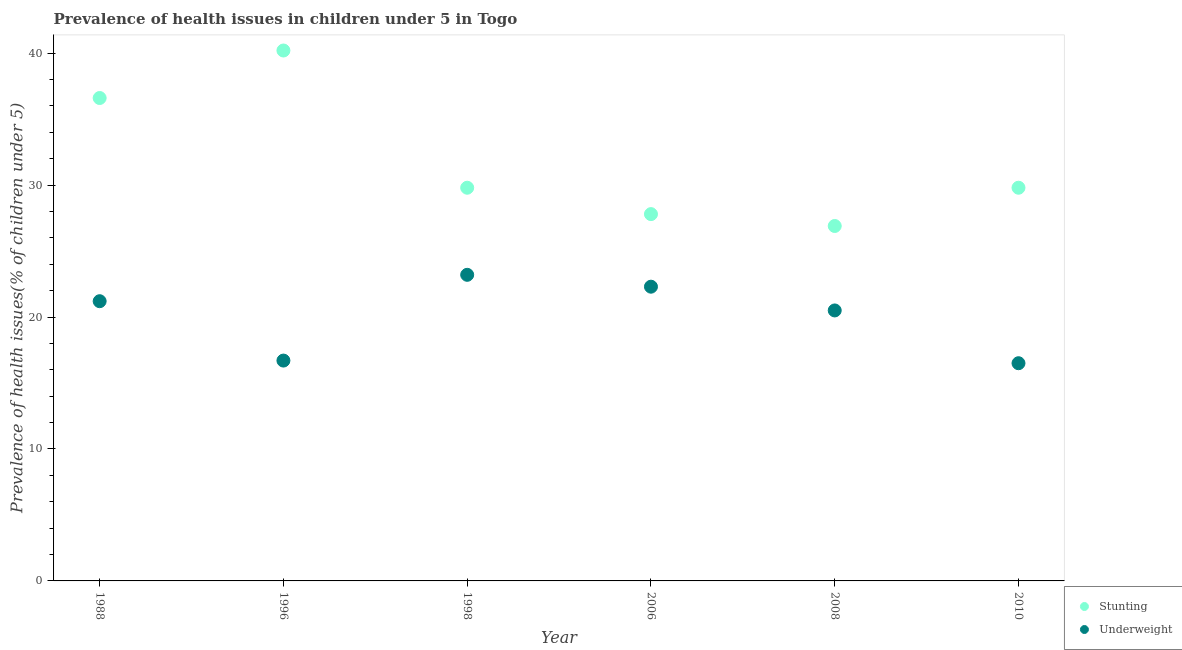Is the number of dotlines equal to the number of legend labels?
Your response must be concise. Yes. Across all years, what is the maximum percentage of underweight children?
Offer a very short reply. 23.2. Across all years, what is the minimum percentage of stunted children?
Give a very brief answer. 26.9. In which year was the percentage of underweight children minimum?
Your answer should be compact. 2010. What is the total percentage of stunted children in the graph?
Ensure brevity in your answer.  191.1. What is the difference between the percentage of stunted children in 1998 and that in 2008?
Your answer should be very brief. 2.9. What is the difference between the percentage of stunted children in 2010 and the percentage of underweight children in 1998?
Provide a succinct answer. 6.6. What is the average percentage of underweight children per year?
Make the answer very short. 20.07. In the year 2008, what is the difference between the percentage of underweight children and percentage of stunted children?
Provide a short and direct response. -6.4. In how many years, is the percentage of underweight children greater than 38 %?
Provide a succinct answer. 0. What is the ratio of the percentage of stunted children in 1988 to that in 2010?
Offer a very short reply. 1.23. Is the percentage of stunted children in 2006 less than that in 2008?
Ensure brevity in your answer.  No. Is the difference between the percentage of stunted children in 1996 and 2008 greater than the difference between the percentage of underweight children in 1996 and 2008?
Your answer should be very brief. Yes. What is the difference between the highest and the second highest percentage of underweight children?
Keep it short and to the point. 0.9. What is the difference between the highest and the lowest percentage of underweight children?
Offer a terse response. 6.7. In how many years, is the percentage of underweight children greater than the average percentage of underweight children taken over all years?
Your answer should be very brief. 4. How many dotlines are there?
Make the answer very short. 2. Does the graph contain any zero values?
Make the answer very short. No. Does the graph contain grids?
Your answer should be compact. No. Where does the legend appear in the graph?
Offer a terse response. Bottom right. How are the legend labels stacked?
Your answer should be very brief. Vertical. What is the title of the graph?
Keep it short and to the point. Prevalence of health issues in children under 5 in Togo. What is the label or title of the Y-axis?
Provide a succinct answer. Prevalence of health issues(% of children under 5). What is the Prevalence of health issues(% of children under 5) in Stunting in 1988?
Make the answer very short. 36.6. What is the Prevalence of health issues(% of children under 5) in Underweight in 1988?
Offer a very short reply. 21.2. What is the Prevalence of health issues(% of children under 5) of Stunting in 1996?
Give a very brief answer. 40.2. What is the Prevalence of health issues(% of children under 5) of Underweight in 1996?
Offer a very short reply. 16.7. What is the Prevalence of health issues(% of children under 5) in Stunting in 1998?
Make the answer very short. 29.8. What is the Prevalence of health issues(% of children under 5) of Underweight in 1998?
Offer a terse response. 23.2. What is the Prevalence of health issues(% of children under 5) in Stunting in 2006?
Offer a terse response. 27.8. What is the Prevalence of health issues(% of children under 5) of Underweight in 2006?
Your answer should be very brief. 22.3. What is the Prevalence of health issues(% of children under 5) of Stunting in 2008?
Give a very brief answer. 26.9. What is the Prevalence of health issues(% of children under 5) of Underweight in 2008?
Provide a succinct answer. 20.5. What is the Prevalence of health issues(% of children under 5) in Stunting in 2010?
Offer a very short reply. 29.8. What is the Prevalence of health issues(% of children under 5) in Underweight in 2010?
Your response must be concise. 16.5. Across all years, what is the maximum Prevalence of health issues(% of children under 5) of Stunting?
Give a very brief answer. 40.2. Across all years, what is the maximum Prevalence of health issues(% of children under 5) of Underweight?
Ensure brevity in your answer.  23.2. Across all years, what is the minimum Prevalence of health issues(% of children under 5) of Stunting?
Provide a succinct answer. 26.9. What is the total Prevalence of health issues(% of children under 5) of Stunting in the graph?
Make the answer very short. 191.1. What is the total Prevalence of health issues(% of children under 5) in Underweight in the graph?
Your answer should be compact. 120.4. What is the difference between the Prevalence of health issues(% of children under 5) of Underweight in 1988 and that in 1996?
Give a very brief answer. 4.5. What is the difference between the Prevalence of health issues(% of children under 5) of Stunting in 1988 and that in 2008?
Make the answer very short. 9.7. What is the difference between the Prevalence of health issues(% of children under 5) in Stunting in 1988 and that in 2010?
Offer a terse response. 6.8. What is the difference between the Prevalence of health issues(% of children under 5) of Stunting in 1996 and that in 1998?
Your response must be concise. 10.4. What is the difference between the Prevalence of health issues(% of children under 5) in Underweight in 1996 and that in 2006?
Your answer should be very brief. -5.6. What is the difference between the Prevalence of health issues(% of children under 5) in Stunting in 1996 and that in 2008?
Give a very brief answer. 13.3. What is the difference between the Prevalence of health issues(% of children under 5) of Underweight in 1996 and that in 2008?
Make the answer very short. -3.8. What is the difference between the Prevalence of health issues(% of children under 5) of Underweight in 1996 and that in 2010?
Give a very brief answer. 0.2. What is the difference between the Prevalence of health issues(% of children under 5) in Stunting in 1998 and that in 2006?
Keep it short and to the point. 2. What is the difference between the Prevalence of health issues(% of children under 5) in Underweight in 1998 and that in 2008?
Offer a terse response. 2.7. What is the difference between the Prevalence of health issues(% of children under 5) in Stunting in 1998 and that in 2010?
Provide a succinct answer. 0. What is the difference between the Prevalence of health issues(% of children under 5) of Stunting in 2006 and that in 2010?
Offer a very short reply. -2. What is the difference between the Prevalence of health issues(% of children under 5) of Stunting in 2008 and that in 2010?
Give a very brief answer. -2.9. What is the difference between the Prevalence of health issues(% of children under 5) in Underweight in 2008 and that in 2010?
Keep it short and to the point. 4. What is the difference between the Prevalence of health issues(% of children under 5) of Stunting in 1988 and the Prevalence of health issues(% of children under 5) of Underweight in 2010?
Give a very brief answer. 20.1. What is the difference between the Prevalence of health issues(% of children under 5) of Stunting in 1996 and the Prevalence of health issues(% of children under 5) of Underweight in 1998?
Ensure brevity in your answer.  17. What is the difference between the Prevalence of health issues(% of children under 5) in Stunting in 1996 and the Prevalence of health issues(% of children under 5) in Underweight in 2006?
Provide a short and direct response. 17.9. What is the difference between the Prevalence of health issues(% of children under 5) of Stunting in 1996 and the Prevalence of health issues(% of children under 5) of Underweight in 2010?
Provide a succinct answer. 23.7. What is the difference between the Prevalence of health issues(% of children under 5) in Stunting in 1998 and the Prevalence of health issues(% of children under 5) in Underweight in 2006?
Provide a short and direct response. 7.5. What is the difference between the Prevalence of health issues(% of children under 5) of Stunting in 2006 and the Prevalence of health issues(% of children under 5) of Underweight in 2008?
Keep it short and to the point. 7.3. What is the average Prevalence of health issues(% of children under 5) in Stunting per year?
Your response must be concise. 31.85. What is the average Prevalence of health issues(% of children under 5) of Underweight per year?
Offer a very short reply. 20.07. In the year 1988, what is the difference between the Prevalence of health issues(% of children under 5) in Stunting and Prevalence of health issues(% of children under 5) in Underweight?
Your answer should be very brief. 15.4. In the year 1998, what is the difference between the Prevalence of health issues(% of children under 5) of Stunting and Prevalence of health issues(% of children under 5) of Underweight?
Offer a very short reply. 6.6. In the year 2006, what is the difference between the Prevalence of health issues(% of children under 5) of Stunting and Prevalence of health issues(% of children under 5) of Underweight?
Ensure brevity in your answer.  5.5. In the year 2010, what is the difference between the Prevalence of health issues(% of children under 5) of Stunting and Prevalence of health issues(% of children under 5) of Underweight?
Your answer should be very brief. 13.3. What is the ratio of the Prevalence of health issues(% of children under 5) in Stunting in 1988 to that in 1996?
Make the answer very short. 0.91. What is the ratio of the Prevalence of health issues(% of children under 5) of Underweight in 1988 to that in 1996?
Provide a short and direct response. 1.27. What is the ratio of the Prevalence of health issues(% of children under 5) in Stunting in 1988 to that in 1998?
Provide a succinct answer. 1.23. What is the ratio of the Prevalence of health issues(% of children under 5) of Underweight in 1988 to that in 1998?
Your answer should be very brief. 0.91. What is the ratio of the Prevalence of health issues(% of children under 5) of Stunting in 1988 to that in 2006?
Offer a very short reply. 1.32. What is the ratio of the Prevalence of health issues(% of children under 5) in Underweight in 1988 to that in 2006?
Your answer should be very brief. 0.95. What is the ratio of the Prevalence of health issues(% of children under 5) of Stunting in 1988 to that in 2008?
Your response must be concise. 1.36. What is the ratio of the Prevalence of health issues(% of children under 5) of Underweight in 1988 to that in 2008?
Ensure brevity in your answer.  1.03. What is the ratio of the Prevalence of health issues(% of children under 5) of Stunting in 1988 to that in 2010?
Ensure brevity in your answer.  1.23. What is the ratio of the Prevalence of health issues(% of children under 5) in Underweight in 1988 to that in 2010?
Provide a short and direct response. 1.28. What is the ratio of the Prevalence of health issues(% of children under 5) of Stunting in 1996 to that in 1998?
Make the answer very short. 1.35. What is the ratio of the Prevalence of health issues(% of children under 5) in Underweight in 1996 to that in 1998?
Give a very brief answer. 0.72. What is the ratio of the Prevalence of health issues(% of children under 5) of Stunting in 1996 to that in 2006?
Your response must be concise. 1.45. What is the ratio of the Prevalence of health issues(% of children under 5) in Underweight in 1996 to that in 2006?
Make the answer very short. 0.75. What is the ratio of the Prevalence of health issues(% of children under 5) in Stunting in 1996 to that in 2008?
Your response must be concise. 1.49. What is the ratio of the Prevalence of health issues(% of children under 5) of Underweight in 1996 to that in 2008?
Offer a terse response. 0.81. What is the ratio of the Prevalence of health issues(% of children under 5) in Stunting in 1996 to that in 2010?
Keep it short and to the point. 1.35. What is the ratio of the Prevalence of health issues(% of children under 5) of Underweight in 1996 to that in 2010?
Provide a succinct answer. 1.01. What is the ratio of the Prevalence of health issues(% of children under 5) in Stunting in 1998 to that in 2006?
Make the answer very short. 1.07. What is the ratio of the Prevalence of health issues(% of children under 5) in Underweight in 1998 to that in 2006?
Offer a terse response. 1.04. What is the ratio of the Prevalence of health issues(% of children under 5) of Stunting in 1998 to that in 2008?
Keep it short and to the point. 1.11. What is the ratio of the Prevalence of health issues(% of children under 5) in Underweight in 1998 to that in 2008?
Your answer should be compact. 1.13. What is the ratio of the Prevalence of health issues(% of children under 5) of Stunting in 1998 to that in 2010?
Offer a very short reply. 1. What is the ratio of the Prevalence of health issues(% of children under 5) in Underweight in 1998 to that in 2010?
Make the answer very short. 1.41. What is the ratio of the Prevalence of health issues(% of children under 5) in Stunting in 2006 to that in 2008?
Give a very brief answer. 1.03. What is the ratio of the Prevalence of health issues(% of children under 5) in Underweight in 2006 to that in 2008?
Ensure brevity in your answer.  1.09. What is the ratio of the Prevalence of health issues(% of children under 5) of Stunting in 2006 to that in 2010?
Your answer should be compact. 0.93. What is the ratio of the Prevalence of health issues(% of children under 5) in Underweight in 2006 to that in 2010?
Ensure brevity in your answer.  1.35. What is the ratio of the Prevalence of health issues(% of children under 5) of Stunting in 2008 to that in 2010?
Provide a succinct answer. 0.9. What is the ratio of the Prevalence of health issues(% of children under 5) in Underweight in 2008 to that in 2010?
Give a very brief answer. 1.24. What is the difference between the highest and the second highest Prevalence of health issues(% of children under 5) in Underweight?
Your answer should be compact. 0.9. What is the difference between the highest and the lowest Prevalence of health issues(% of children under 5) in Stunting?
Provide a short and direct response. 13.3. 